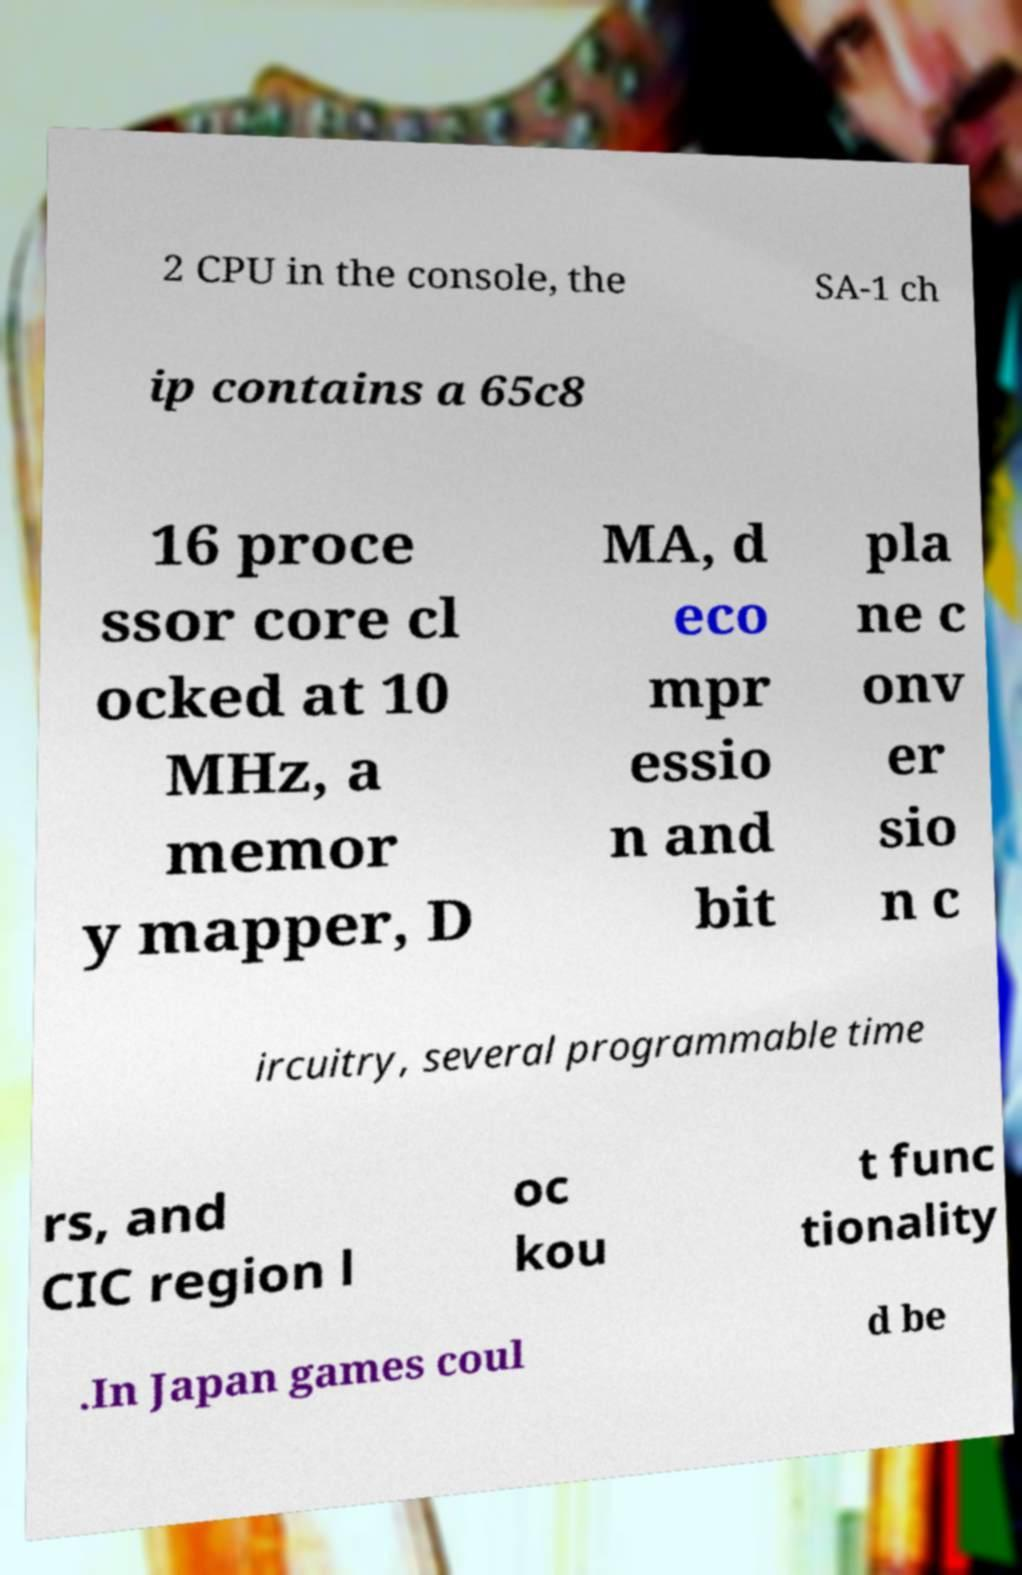What messages or text are displayed in this image? I need them in a readable, typed format. 2 CPU in the console, the SA-1 ch ip contains a 65c8 16 proce ssor core cl ocked at 10 MHz, a memor y mapper, D MA, d eco mpr essio n and bit pla ne c onv er sio n c ircuitry, several programmable time rs, and CIC region l oc kou t func tionality .In Japan games coul d be 